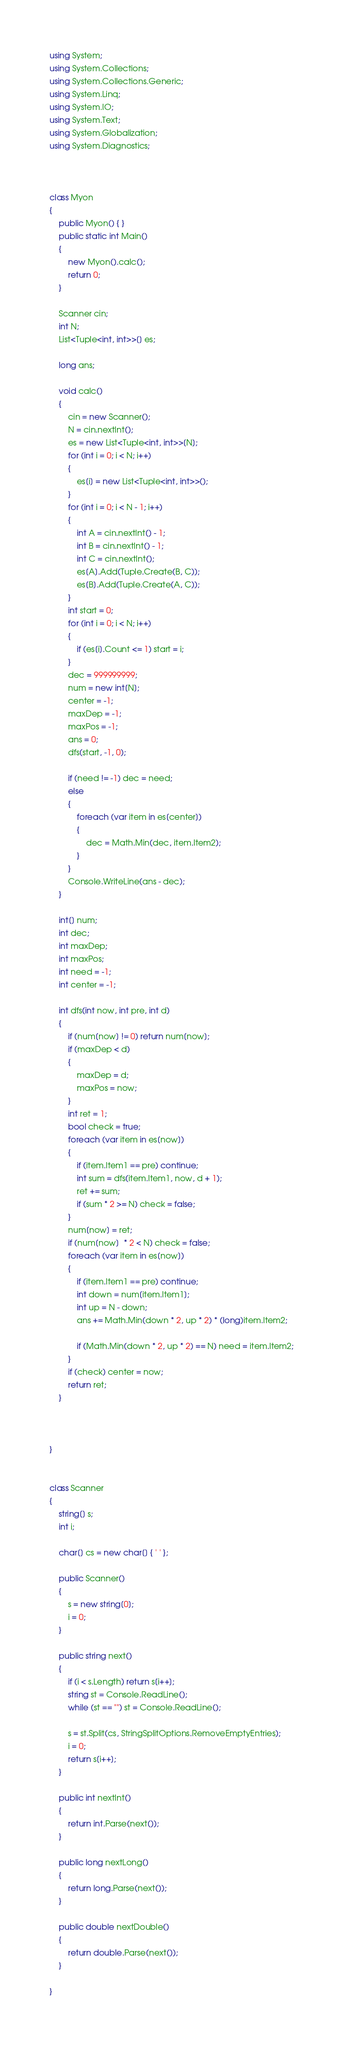Convert code to text. <code><loc_0><loc_0><loc_500><loc_500><_C#_>using System;
using System.Collections;
using System.Collections.Generic;
using System.Linq;
using System.IO;
using System.Text;
using System.Globalization;
using System.Diagnostics;



class Myon
{
    public Myon() { }
    public static int Main()
    {
        new Myon().calc();
        return 0;
    }

    Scanner cin;
    int N;
    List<Tuple<int, int>>[] es;

    long ans;

    void calc()
    {
        cin = new Scanner();
        N = cin.nextInt();
        es = new List<Tuple<int, int>>[N];
        for (int i = 0; i < N; i++)
        {
            es[i] = new List<Tuple<int, int>>();
        }
        for (int i = 0; i < N - 1; i++)
        {
            int A = cin.nextInt() - 1;
            int B = cin.nextInt() - 1;
            int C = cin.nextInt();
            es[A].Add(Tuple.Create(B, C));
            es[B].Add(Tuple.Create(A, C));
        }
        int start = 0;
        for (int i = 0; i < N; i++)
        {
            if (es[i].Count <= 1) start = i;
        }
        dec = 999999999;
        num = new int[N];
        center = -1;
        maxDep = -1;
        maxPos = -1;
        ans = 0;
        dfs(start, -1, 0);

        if (need != -1) dec = need;
        else
        {
            foreach (var item in es[center])
            {
                dec = Math.Min(dec, item.Item2);
            }
        }
        Console.WriteLine(ans - dec);
    }

    int[] num;
    int dec;
    int maxDep;
    int maxPos;
    int need = -1;
    int center = -1;

    int dfs(int now, int pre, int d)
    {
        if (num[now] != 0) return num[now];
        if (maxDep < d)
        {
            maxDep = d;
            maxPos = now;
        }
        int ret = 1;
        bool check = true;
        foreach (var item in es[now])
        {
            if (item.Item1 == pre) continue;
            int sum = dfs(item.Item1, now, d + 1);
            ret += sum;
            if (sum * 2 >= N) check = false;
        }
        num[now] = ret;
        if (num[now]  * 2 < N) check = false;
        foreach (var item in es[now])
        {
            if (item.Item1 == pre) continue;
            int down = num[item.Item1];
            int up = N - down;
            ans += Math.Min(down * 2, up * 2) * (long)item.Item2;

            if (Math.Min(down * 2, up * 2) == N) need = item.Item2;
        }
        if (check) center = now;
        return ret;
    }



}


class Scanner
{
    string[] s;
    int i;

    char[] cs = new char[] { ' ' };

    public Scanner()
    {
        s = new string[0];
        i = 0;
    }

    public string next()
    {
        if (i < s.Length) return s[i++];
        string st = Console.ReadLine();
        while (st == "") st = Console.ReadLine();

        s = st.Split(cs, StringSplitOptions.RemoveEmptyEntries);
        i = 0;
        return s[i++];
    }

    public int nextInt()
    {
        return int.Parse(next());
    }

    public long nextLong()
    {
        return long.Parse(next());
    }

    public double nextDouble()
    {
        return double.Parse(next());
    }

}</code> 